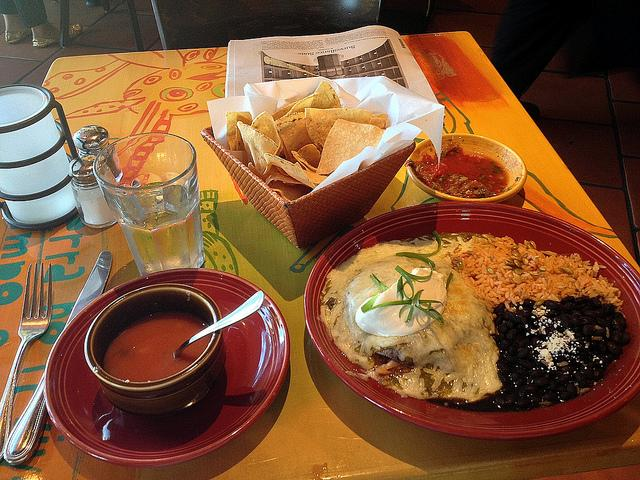How many people will dine at this table? one 